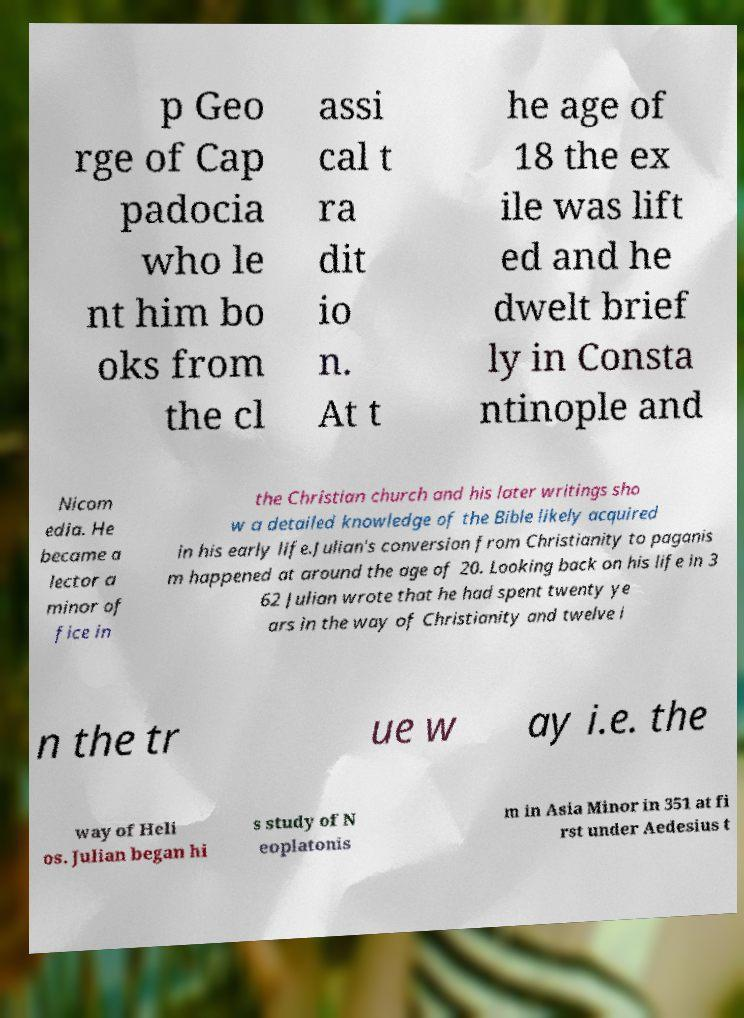Please read and relay the text visible in this image. What does it say? p Geo rge of Cap padocia who le nt him bo oks from the cl assi cal t ra dit io n. At t he age of 18 the ex ile was lift ed and he dwelt brief ly in Consta ntinople and Nicom edia. He became a lector a minor of fice in the Christian church and his later writings sho w a detailed knowledge of the Bible likely acquired in his early life.Julian's conversion from Christianity to paganis m happened at around the age of 20. Looking back on his life in 3 62 Julian wrote that he had spent twenty ye ars in the way of Christianity and twelve i n the tr ue w ay i.e. the way of Heli os. Julian began hi s study of N eoplatonis m in Asia Minor in 351 at fi rst under Aedesius t 